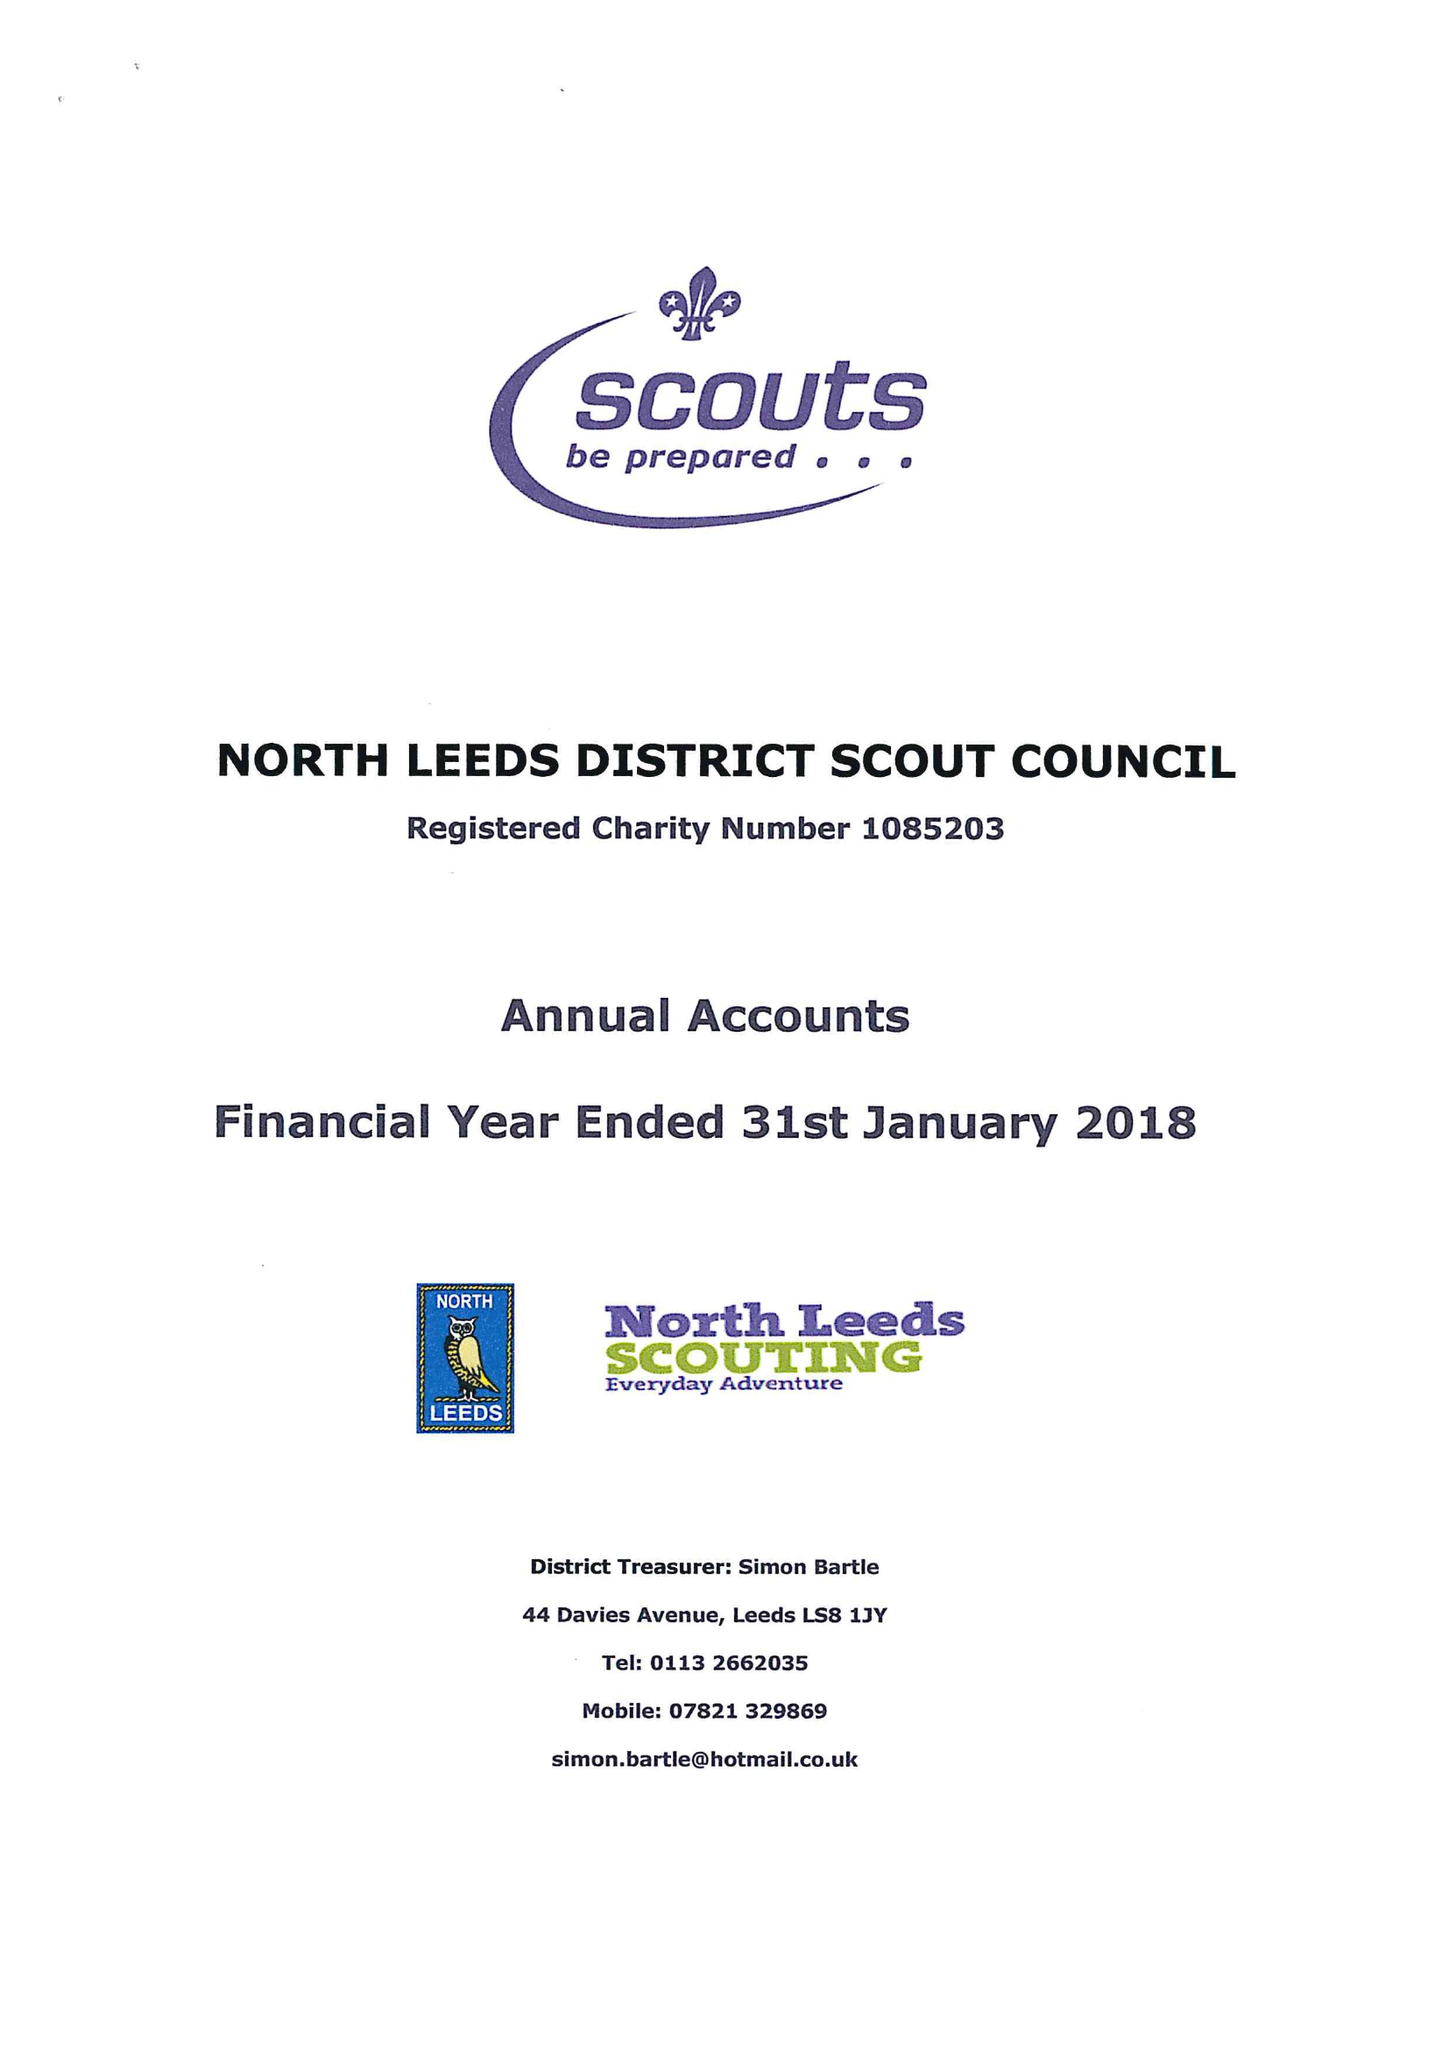What is the value for the address__street_line?
Answer the question using a single word or phrase. 27 THE FAIRWAY 